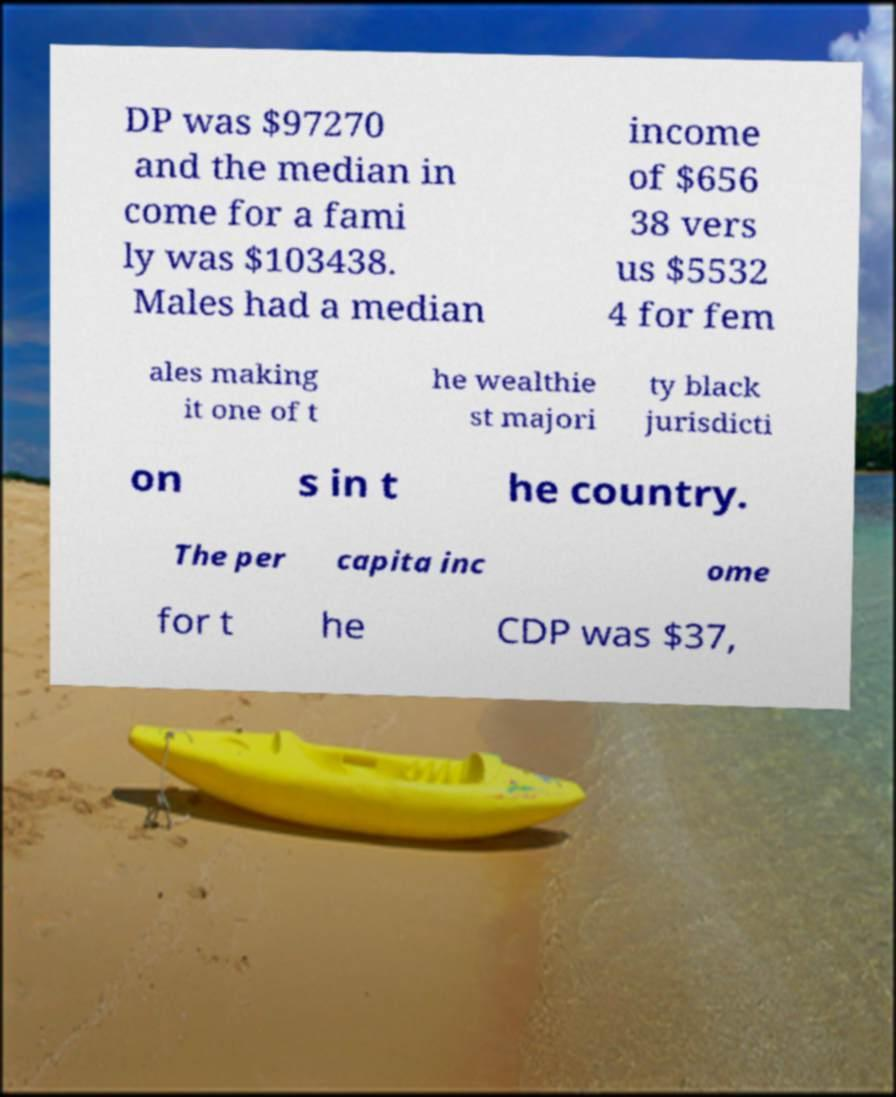There's text embedded in this image that I need extracted. Can you transcribe it verbatim? DP was $97270 and the median in come for a fami ly was $103438. Males had a median income of $656 38 vers us $5532 4 for fem ales making it one of t he wealthie st majori ty black jurisdicti on s in t he country. The per capita inc ome for t he CDP was $37, 